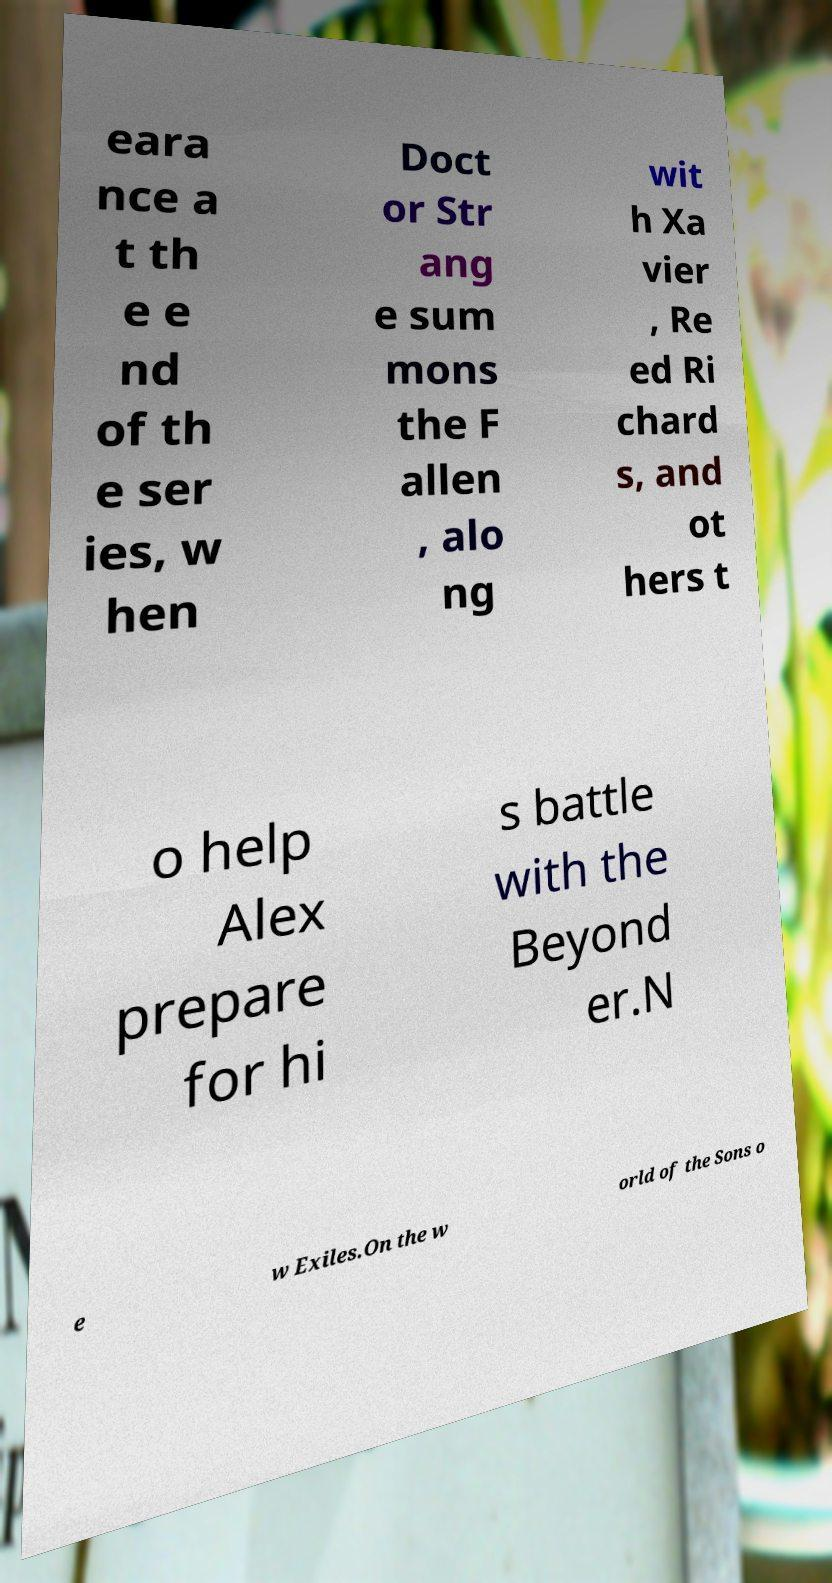Can you read and provide the text displayed in the image?This photo seems to have some interesting text. Can you extract and type it out for me? eara nce a t th e e nd of th e ser ies, w hen Doct or Str ang e sum mons the F allen , alo ng wit h Xa vier , Re ed Ri chard s, and ot hers t o help Alex prepare for hi s battle with the Beyond er.N e w Exiles.On the w orld of the Sons o 